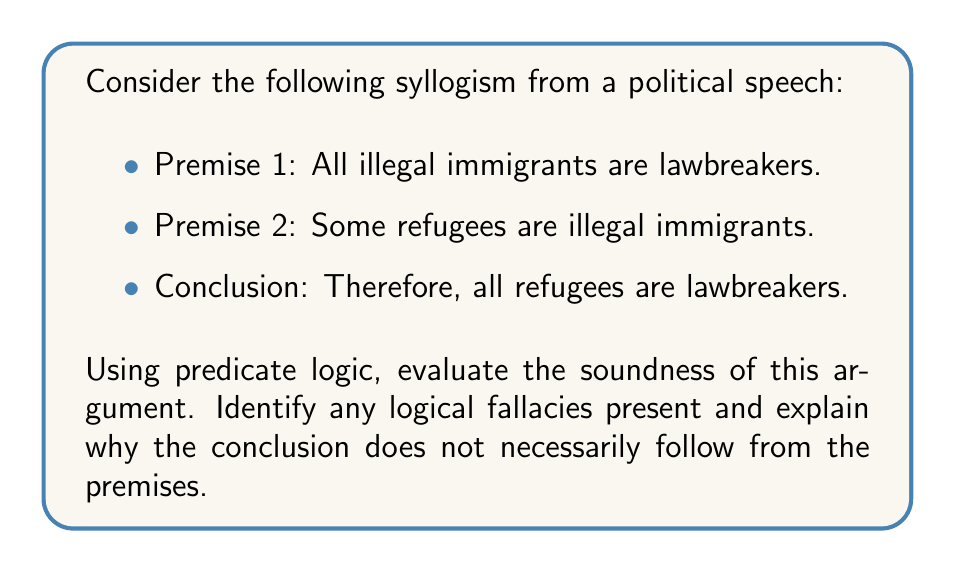Teach me how to tackle this problem. To evaluate this syllogism using predicate logic, let's define our predicates:

$I(x)$: x is an illegal immigrant
$L(x)$: x is a lawbreaker
$R(x)$: x is a refugee

Now, we can translate the premises and conclusion into predicate logic:

Premise 1: $\forall x (I(x) \rightarrow L(x))$
Premise 2: $\exists x (R(x) \land I(x))$
Conclusion: $\forall x (R(x) \rightarrow L(x))$

To analyze the soundness of this argument, we need to check if the conclusion logically follows from the premises.

1. Premise 1 states that all illegal immigrants are lawbreakers, which is logically valid.

2. Premise 2 states that some refugees are illegal immigrants, which is also logically valid.

3. However, the conclusion does not logically follow from these premises. This is an example of the "fallacy of the undistributed middle" or "illicit minor."

The problem arises because the middle term (illegal immigrants) is not distributed in either premise. In other words, we only know that:
a) All illegal immigrants are lawbreakers
b) Some refugees are illegal immigrants

From this, we cannot conclude that all refugees are lawbreakers. We can only conclude that some refugees are lawbreakers.

A valid conclusion would be:
$\exists x (R(x) \land L(x))$

This translates to: "Some refugees are lawbreakers."

The original argument attempts to make a universal claim (all refugees) based on a particular premise (some refugees), which is not logically sound.

In terms of set theory, we can visualize this as:

[asy]
unitsize(1cm);
draw(circle((0,0),2));
draw(circle((1,0),2));
draw(circle((-1,0),2));
label("Illegal Immigrants", (0,2.5));
label("Lawbreakers", (1,2.5));
label("Refugees", (-1,2.5));
label("Some", (-0.5,0));
[/asy]

The diagram shows that while all illegal immigrants are lawbreakers, and some refugees are illegal immigrants, we cannot conclude that all refugees are lawbreakers.
Answer: The syllogism is unsound due to the fallacy of the undistributed middle. A valid conclusion would be $\exists x (R(x) \land L(x))$, meaning "Some refugees are lawbreakers," not "All refugees are lawbreakers." 